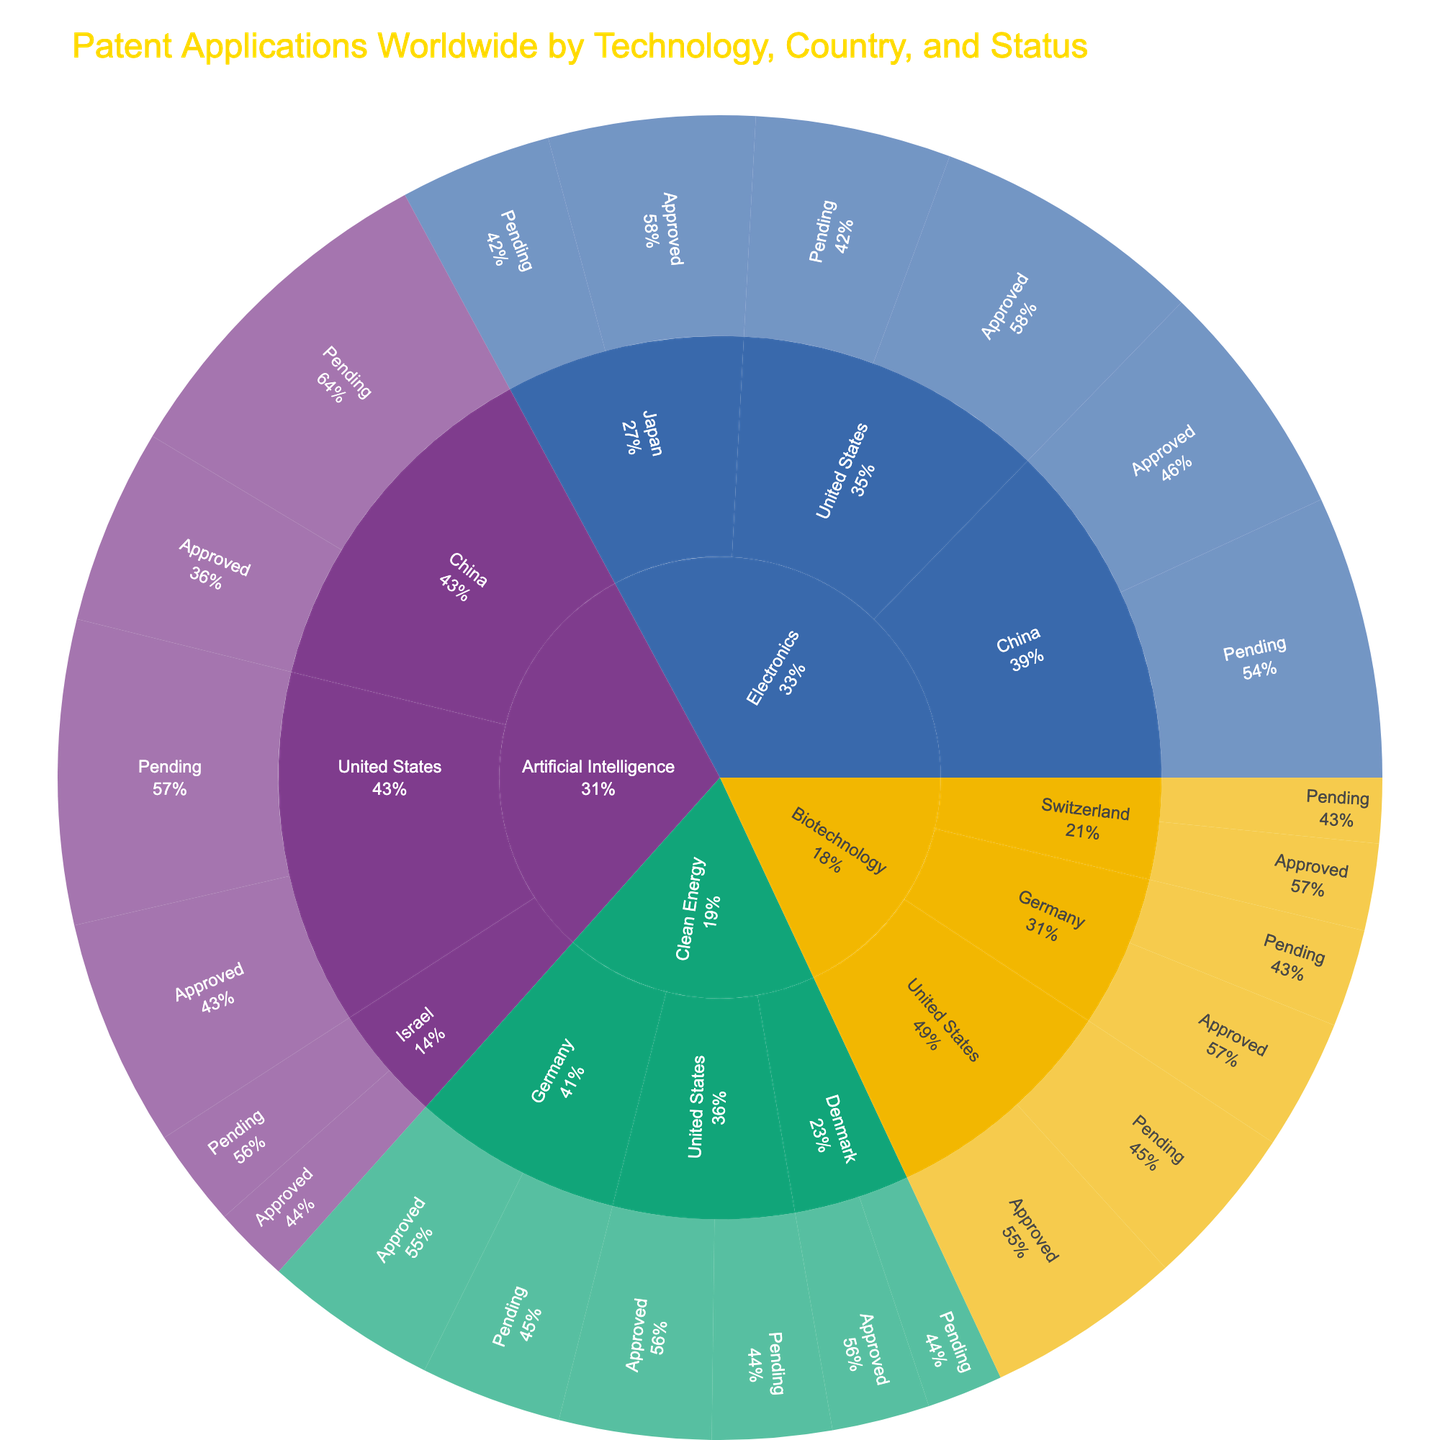What's the title of the figure? The title of the figure is clearly displayed at the top. It provides an overview of what the plot represents.
Answer: Patent Applications Worldwide by Technology, Country, and Status Which technology sector has the highest number of approved patents? Look at the outermost ring labeled "Approved" and check the sectors with the biggest slices.
Answer: Electronics How many patent applications in the United States are pending? Navigate to the path "United States" > "Pending" and sum the counts from all the sectors.
Answer: 8200 What's the total number of Clean Energy patent applications in Germany? Identify the segments under Clean Energy for Germany and sum the counts for both Approved and Pending statuses.
Answer: 2900 Which country has the largest number of Artificial Intelligence patent applications pending? Find the "Artificial Intelligence" sector, then drill down to "Pending" status and compare the slices for different countries.
Answer: China What is the ratio of approved to pending patents in Biotechnology in Germany? Identify the counts for Biotechnology in Germany for both Approved and Pending statuses, then compute the ratio.
Answer: 1200:900 or 4:3 How many more Electronics patents are pending in China compared to the United States? Compare the counts of pending Electronics patents in China and the United States and compute the difference.
Answer: 800 Which technology sector has the smallest number of pending patent applications in Israel? Locate Israel under each technology's Pending status and compare the values.
Answer: Artificial Intelligence What percentage of Biotechnology patents in Switzerland are approved? Calculate the percentage by taking the count of approved patents and dividing it by the total number of Biotechnology patents in Switzerland, then multiply by 100.
Answer: 57.14% Compare the total number of approved patents in the United States with the total number of approved patents in Germany. Which country has more? Sum the counts of approved patents across all sectors for both countries and compare the totals.
Answer: United States 